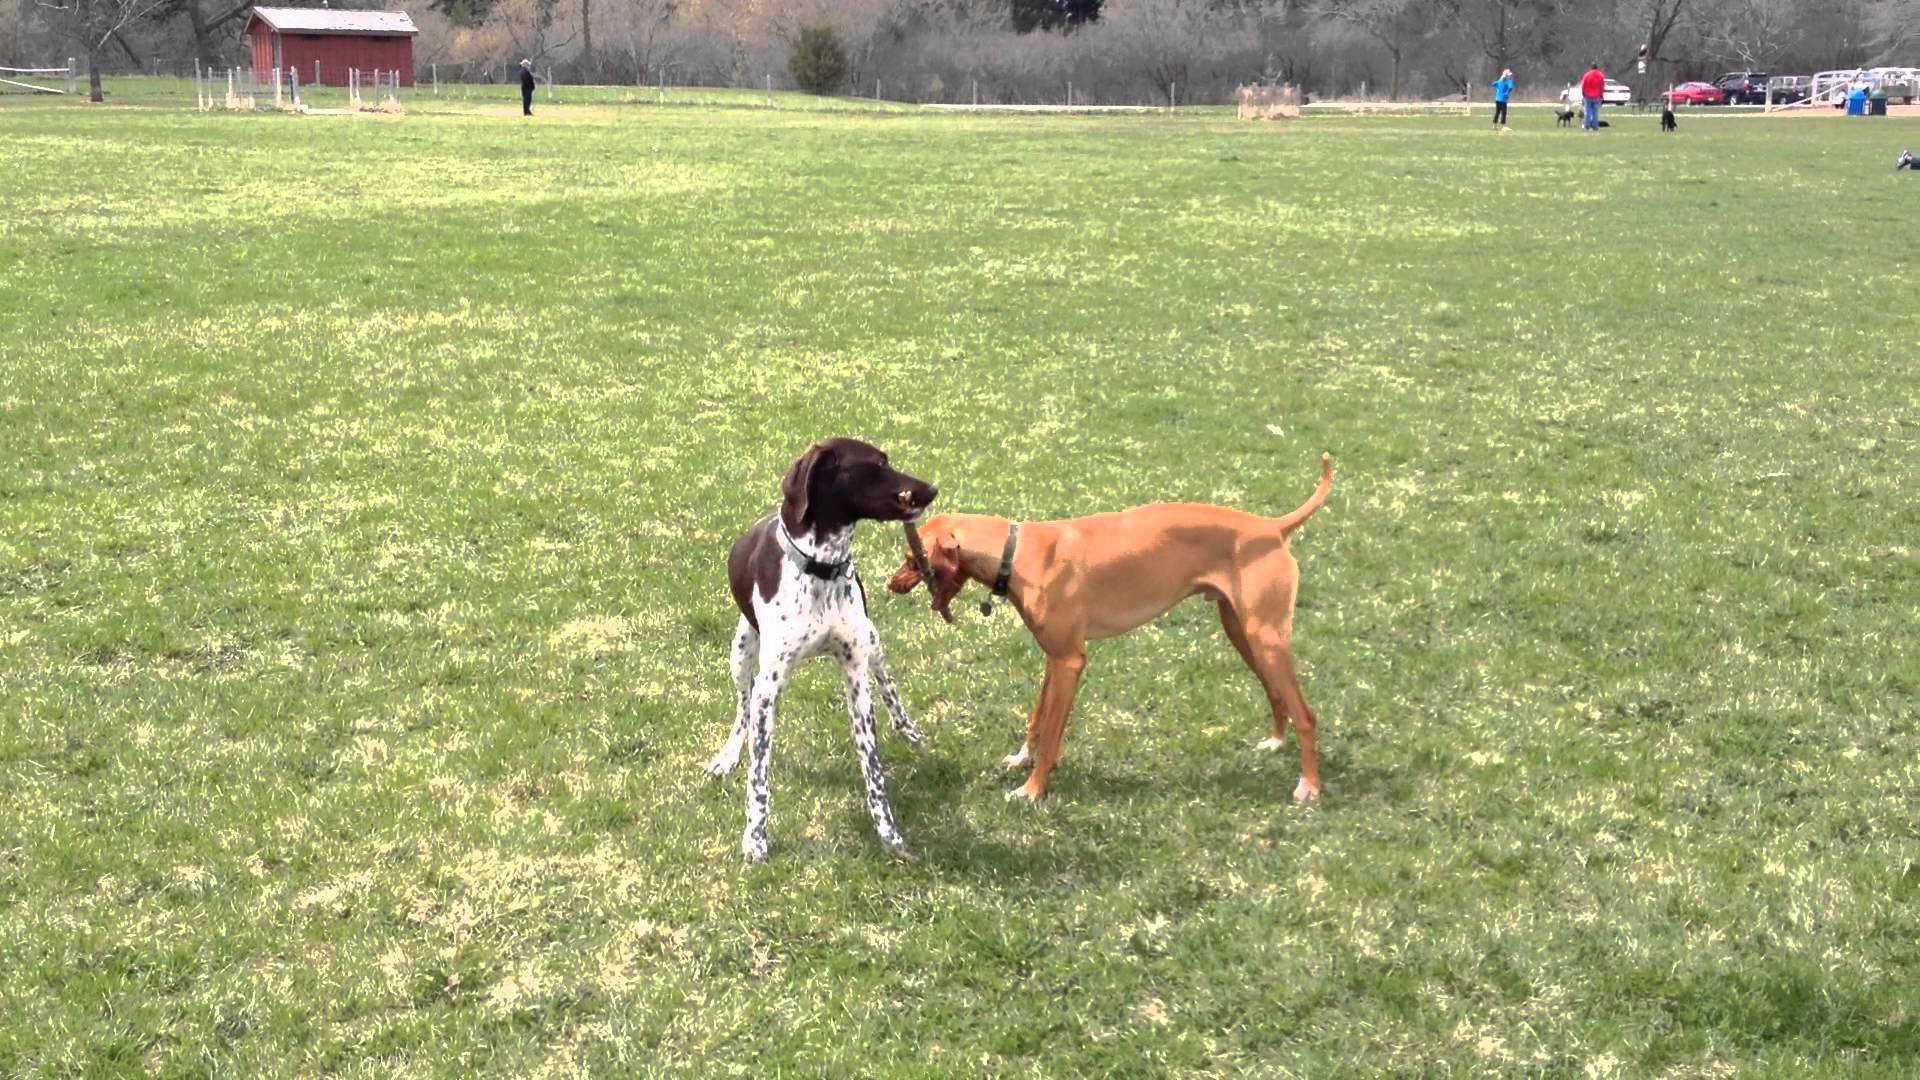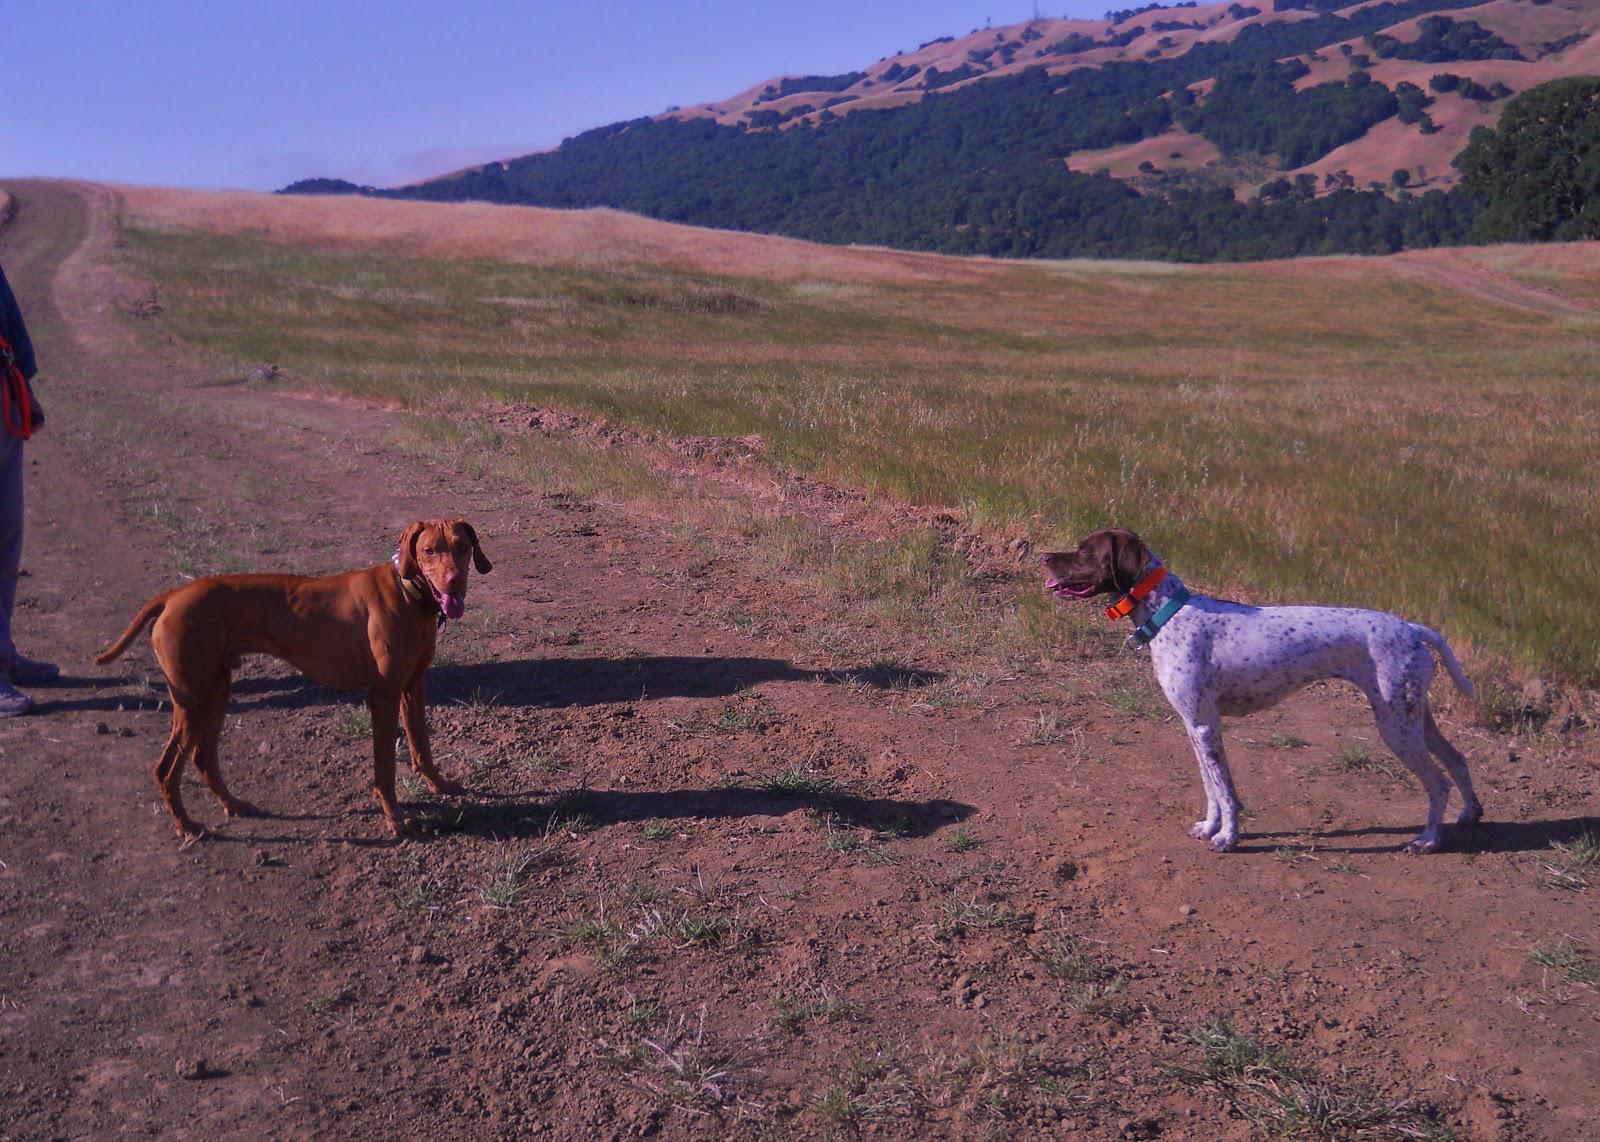The first image is the image on the left, the second image is the image on the right. Assess this claim about the two images: "In one image, exactly four dogs are at an outdoor location with one or more people.". Correct or not? Answer yes or no. No. The first image is the image on the left, the second image is the image on the right. Analyze the images presented: Is the assertion "At least some of the dogs are on a leash." valid? Answer yes or no. No. 